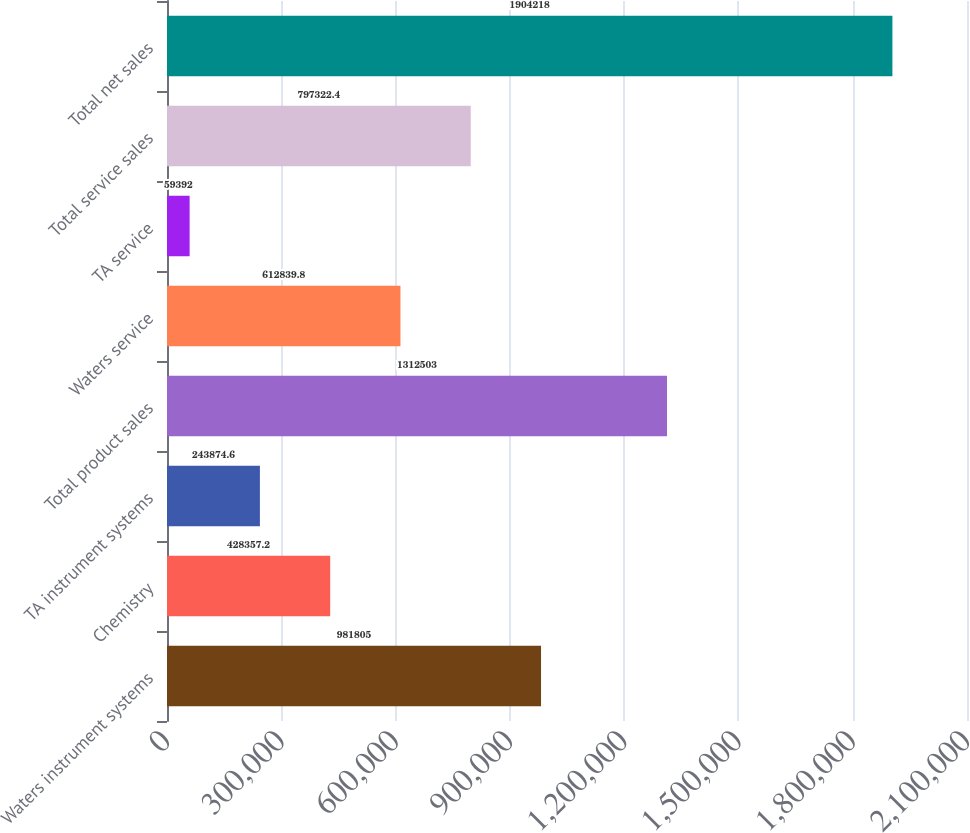Convert chart to OTSL. <chart><loc_0><loc_0><loc_500><loc_500><bar_chart><fcel>Waters instrument systems<fcel>Chemistry<fcel>TA instrument systems<fcel>Total product sales<fcel>Waters service<fcel>TA service<fcel>Total service sales<fcel>Total net sales<nl><fcel>981805<fcel>428357<fcel>243875<fcel>1.3125e+06<fcel>612840<fcel>59392<fcel>797322<fcel>1.90422e+06<nl></chart> 